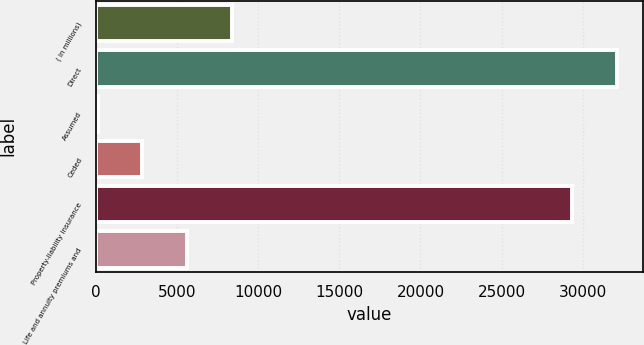Convert chart. <chart><loc_0><loc_0><loc_500><loc_500><bar_chart><fcel>( in millions)<fcel>Direct<fcel>Assumed<fcel>Ceded<fcel>Property-liability insurance<fcel>Life and annuity premiums and<nl><fcel>8359.6<fcel>32100.4<fcel>85<fcel>2843.2<fcel>29342.2<fcel>5601.4<nl></chart> 